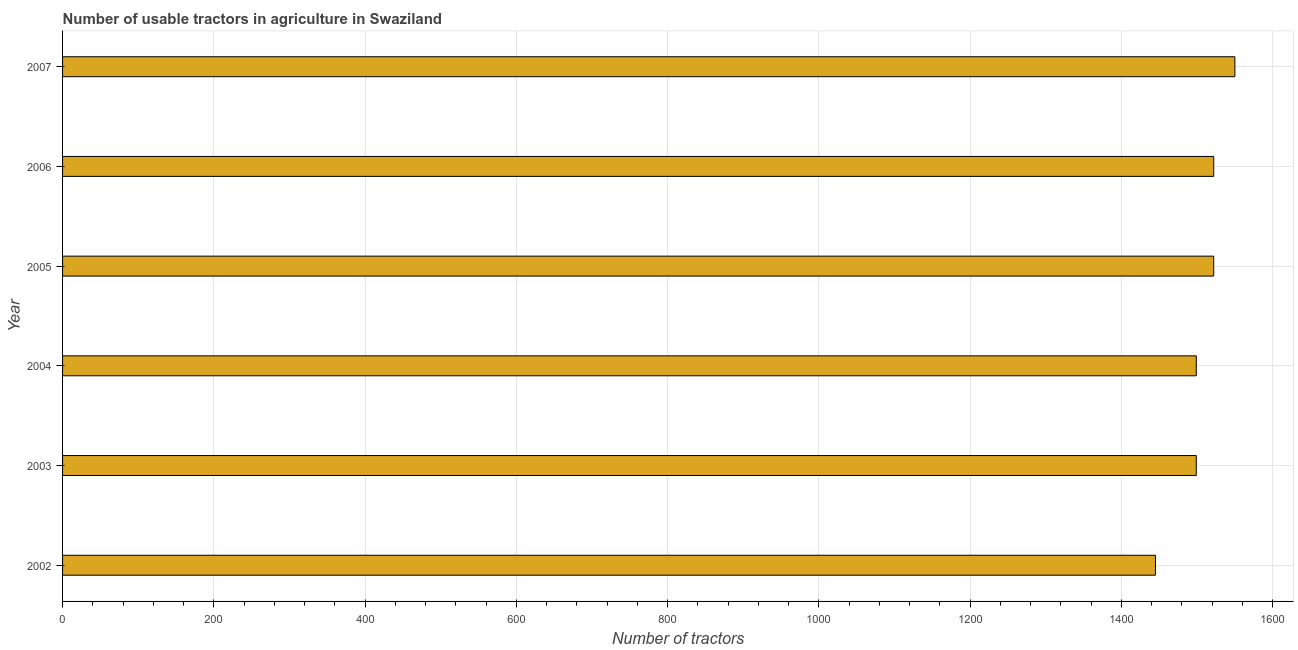Does the graph contain any zero values?
Your answer should be very brief. No. What is the title of the graph?
Offer a terse response. Number of usable tractors in agriculture in Swaziland. What is the label or title of the X-axis?
Make the answer very short. Number of tractors. What is the number of tractors in 2003?
Provide a short and direct response. 1499. Across all years, what is the maximum number of tractors?
Offer a terse response. 1550. Across all years, what is the minimum number of tractors?
Your response must be concise. 1445. In which year was the number of tractors minimum?
Your response must be concise. 2002. What is the sum of the number of tractors?
Offer a terse response. 9037. What is the difference between the number of tractors in 2002 and 2007?
Give a very brief answer. -105. What is the average number of tractors per year?
Offer a terse response. 1506. What is the median number of tractors?
Your answer should be very brief. 1510.5. In how many years, is the number of tractors greater than 320 ?
Ensure brevity in your answer.  6. What is the ratio of the number of tractors in 2003 to that in 2004?
Offer a very short reply. 1. Is the sum of the number of tractors in 2004 and 2006 greater than the maximum number of tractors across all years?
Make the answer very short. Yes. What is the difference between the highest and the lowest number of tractors?
Your response must be concise. 105. In how many years, is the number of tractors greater than the average number of tractors taken over all years?
Give a very brief answer. 3. How many bars are there?
Ensure brevity in your answer.  6. Are all the bars in the graph horizontal?
Your answer should be compact. Yes. How many years are there in the graph?
Your response must be concise. 6. What is the Number of tractors of 2002?
Make the answer very short. 1445. What is the Number of tractors of 2003?
Provide a succinct answer. 1499. What is the Number of tractors of 2004?
Offer a terse response. 1499. What is the Number of tractors of 2005?
Make the answer very short. 1522. What is the Number of tractors in 2006?
Make the answer very short. 1522. What is the Number of tractors of 2007?
Ensure brevity in your answer.  1550. What is the difference between the Number of tractors in 2002 and 2003?
Your answer should be compact. -54. What is the difference between the Number of tractors in 2002 and 2004?
Your answer should be very brief. -54. What is the difference between the Number of tractors in 2002 and 2005?
Your response must be concise. -77. What is the difference between the Number of tractors in 2002 and 2006?
Provide a succinct answer. -77. What is the difference between the Number of tractors in 2002 and 2007?
Keep it short and to the point. -105. What is the difference between the Number of tractors in 2003 and 2004?
Your response must be concise. 0. What is the difference between the Number of tractors in 2003 and 2006?
Your answer should be very brief. -23. What is the difference between the Number of tractors in 2003 and 2007?
Offer a very short reply. -51. What is the difference between the Number of tractors in 2004 and 2005?
Provide a short and direct response. -23. What is the difference between the Number of tractors in 2004 and 2006?
Your answer should be compact. -23. What is the difference between the Number of tractors in 2004 and 2007?
Your response must be concise. -51. What is the difference between the Number of tractors in 2005 and 2006?
Offer a very short reply. 0. What is the difference between the Number of tractors in 2005 and 2007?
Your answer should be very brief. -28. What is the difference between the Number of tractors in 2006 and 2007?
Your answer should be compact. -28. What is the ratio of the Number of tractors in 2002 to that in 2005?
Give a very brief answer. 0.95. What is the ratio of the Number of tractors in 2002 to that in 2006?
Give a very brief answer. 0.95. What is the ratio of the Number of tractors in 2002 to that in 2007?
Ensure brevity in your answer.  0.93. What is the ratio of the Number of tractors in 2003 to that in 2004?
Provide a succinct answer. 1. What is the ratio of the Number of tractors in 2003 to that in 2005?
Make the answer very short. 0.98. What is the ratio of the Number of tractors in 2004 to that in 2006?
Offer a terse response. 0.98. What is the ratio of the Number of tractors in 2005 to that in 2006?
Give a very brief answer. 1. What is the ratio of the Number of tractors in 2005 to that in 2007?
Offer a terse response. 0.98. What is the ratio of the Number of tractors in 2006 to that in 2007?
Offer a terse response. 0.98. 